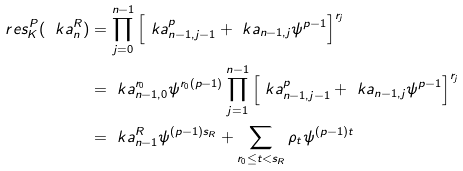<formula> <loc_0><loc_0><loc_500><loc_500>\ r e s _ { K } ^ { P } ( \ k a ^ { R } _ { n } ) & = \prod _ { j = 0 } ^ { n - 1 } \left [ \ k a ^ { p } _ { n - 1 , j - 1 } + \ k a _ { n - 1 , j } \psi ^ { p - 1 } \right ] ^ { r _ { j } } \\ & = \ k a ^ { r _ { 0 } } _ { n - 1 , 0 } \psi ^ { r _ { 0 } ( p - 1 ) } \prod _ { j = 1 } ^ { n - 1 } \left [ \ k a ^ { p } _ { n - 1 , j - 1 } + \ k a _ { n - 1 , j } \psi ^ { p - 1 } \right ] ^ { r _ { j } } \\ & = \ k a ^ { R } _ { n - 1 } \psi ^ { ( p - 1 ) s _ { R } } + \sum _ { r _ { 0 } \leq t < s _ { R } } \rho _ { t } \psi ^ { ( p - 1 ) t }</formula> 